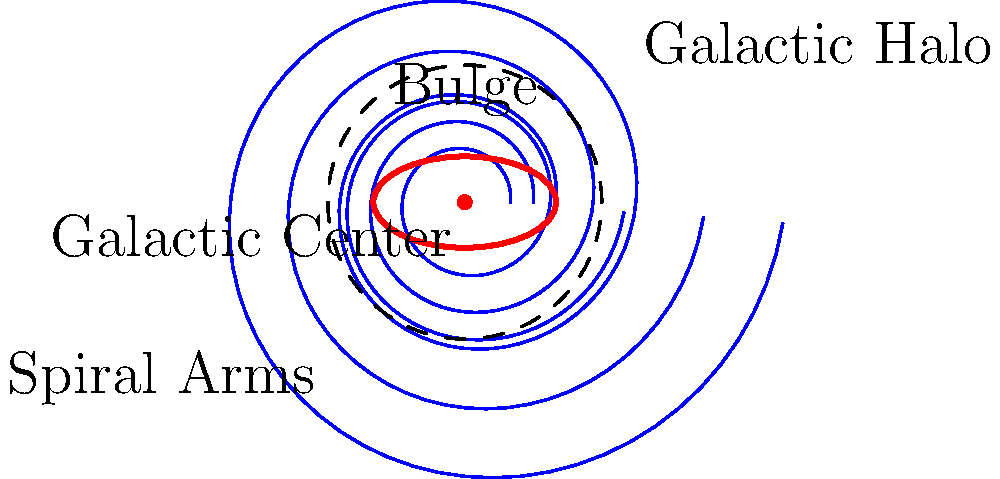In this spiral galaxy illustration, which component is represented by the dashed circle encompassing the entire structure? Let's break down the components of a spiral galaxy as shown in the illustration:

1. The center of the galaxy is marked as the "Galactic Center," which is the densest part of the galaxy.

2. Surrounding the center, we see an elliptical shape labeled as the "Bulge." This is a concentrated group of older stars.

3. Extending outward from the bulge are the "Spiral Arms," which are the characteristic feature of spiral galaxies. These contain younger stars, gas, and dust.

4. Finally, encompassing the entire visible structure of the galaxy, we see a dashed circle. This represents the "Galactic Halo."

The Galactic Halo is a spherical component surrounding the main visible part of a galaxy. It extends far beyond the spiral arms and contains older stars, globular clusters, and dark matter. While it's not always visible to the naked eye, it plays a crucial role in the galaxy's structure and dynamics.

In this illustration, the dashed circle is specifically labeled as the "Galactic Halo," which directly answers the question.
Answer: Galactic Halo 